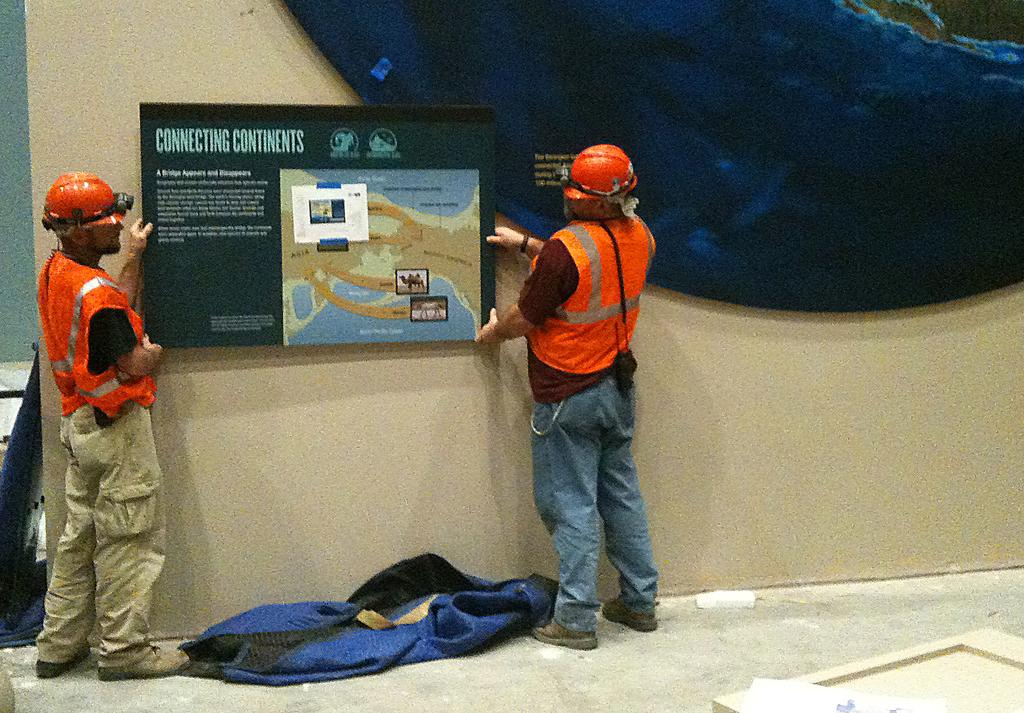How many people are in the image? There are two people in the image. What are the people wearing on their heads? The people are wearing orange helmets. Where are the people standing? The people are standing on the floor. What are the people holding? The people are holding a board with text on it. What is the board being used for? The board is being hung on a wall. What is the color of the wall? The wall has a cream and blue color. What type of punishment is being administered to the writer in the image? There is no writer or punishment present in the image. The two people are holding a board with text on it, and they are not being punished. 